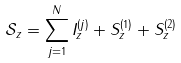<formula> <loc_0><loc_0><loc_500><loc_500>\mathcal { S } _ { z } = \sum _ { j = 1 } ^ { N } I _ { z } ^ { ( j ) } + S _ { z } ^ { ( 1 ) } + S _ { z } ^ { ( 2 ) }</formula> 